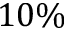<formula> <loc_0><loc_0><loc_500><loc_500>1 0 \%</formula> 